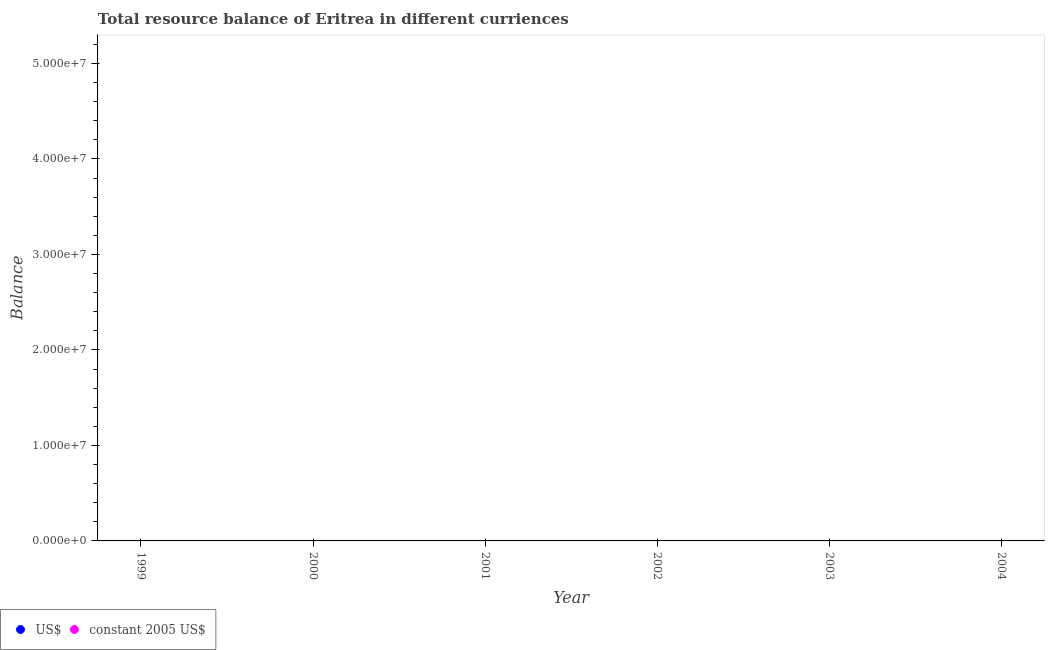How many different coloured dotlines are there?
Your answer should be compact. 0. Across all years, what is the minimum resource balance in us$?
Your answer should be compact. 0. In how many years, is the resource balance in us$ greater than 28000000 units?
Make the answer very short. 0. In how many years, is the resource balance in constant us$ greater than the average resource balance in constant us$ taken over all years?
Your response must be concise. 0. Is the resource balance in us$ strictly less than the resource balance in constant us$ over the years?
Ensure brevity in your answer.  No. What is the difference between two consecutive major ticks on the Y-axis?
Give a very brief answer. 1.00e+07. Are the values on the major ticks of Y-axis written in scientific E-notation?
Ensure brevity in your answer.  Yes. Does the graph contain any zero values?
Provide a short and direct response. Yes. Does the graph contain grids?
Provide a succinct answer. No. What is the title of the graph?
Keep it short and to the point. Total resource balance of Eritrea in different curriences. Does "Urban" appear as one of the legend labels in the graph?
Your answer should be compact. No. What is the label or title of the Y-axis?
Provide a succinct answer. Balance. What is the Balance of US$ in 2000?
Your answer should be very brief. 0. What is the Balance of US$ in 2001?
Your response must be concise. 0. What is the Balance of constant 2005 US$ in 2002?
Offer a terse response. 0. What is the Balance in US$ in 2003?
Your answer should be very brief. 0. What is the Balance in constant 2005 US$ in 2003?
Offer a very short reply. 0. What is the Balance of US$ in 2004?
Your answer should be very brief. 0. What is the Balance in constant 2005 US$ in 2004?
Offer a terse response. 0. 